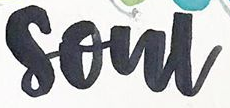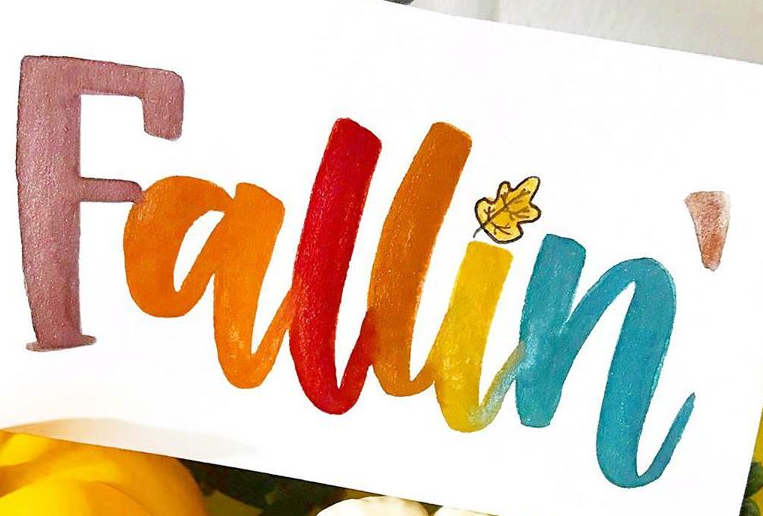Read the text from these images in sequence, separated by a semicolon. soul; Fallin 